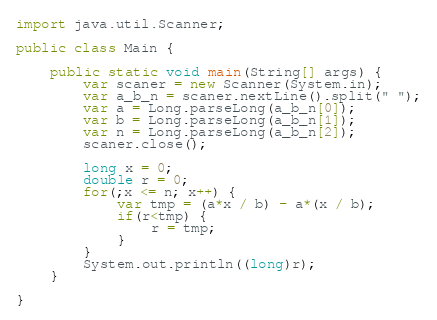<code> <loc_0><loc_0><loc_500><loc_500><_Java_>import java.util.Scanner;

public class Main {

    public static void main(String[] args) {
        var scaner = new Scanner(System.in);
        var a_b_n = scaner.nextLine().split(" ");
        var a = Long.parseLong(a_b_n[0]);
        var b = Long.parseLong(a_b_n[1]);
        var n = Long.parseLong(a_b_n[2]);
        scaner.close();

        long x = 0;
        double r = 0;
        for(;x <= n; x++) {
            var tmp = (a*x / b) - a*(x / b);
            if(r<tmp) {
                r = tmp;
            }
        }
        System.out.println((long)r);
    }

}
</code> 